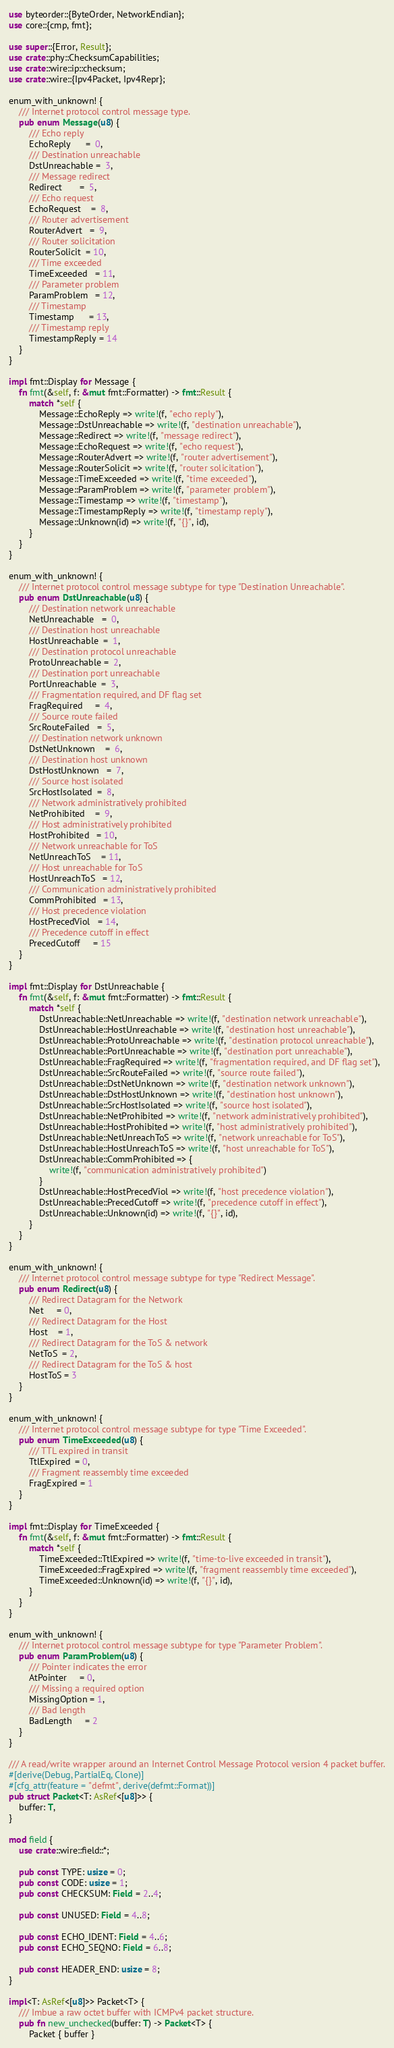Convert code to text. <code><loc_0><loc_0><loc_500><loc_500><_Rust_>use byteorder::{ByteOrder, NetworkEndian};
use core::{cmp, fmt};

use super::{Error, Result};
use crate::phy::ChecksumCapabilities;
use crate::wire::ip::checksum;
use crate::wire::{Ipv4Packet, Ipv4Repr};

enum_with_unknown! {
    /// Internet protocol control message type.
    pub enum Message(u8) {
        /// Echo reply
        EchoReply      =  0,
        /// Destination unreachable
        DstUnreachable =  3,
        /// Message redirect
        Redirect       =  5,
        /// Echo request
        EchoRequest    =  8,
        /// Router advertisement
        RouterAdvert   =  9,
        /// Router solicitation
        RouterSolicit  = 10,
        /// Time exceeded
        TimeExceeded   = 11,
        /// Parameter problem
        ParamProblem   = 12,
        /// Timestamp
        Timestamp      = 13,
        /// Timestamp reply
        TimestampReply = 14
    }
}

impl fmt::Display for Message {
    fn fmt(&self, f: &mut fmt::Formatter) -> fmt::Result {
        match *self {
            Message::EchoReply => write!(f, "echo reply"),
            Message::DstUnreachable => write!(f, "destination unreachable"),
            Message::Redirect => write!(f, "message redirect"),
            Message::EchoRequest => write!(f, "echo request"),
            Message::RouterAdvert => write!(f, "router advertisement"),
            Message::RouterSolicit => write!(f, "router solicitation"),
            Message::TimeExceeded => write!(f, "time exceeded"),
            Message::ParamProblem => write!(f, "parameter problem"),
            Message::Timestamp => write!(f, "timestamp"),
            Message::TimestampReply => write!(f, "timestamp reply"),
            Message::Unknown(id) => write!(f, "{}", id),
        }
    }
}

enum_with_unknown! {
    /// Internet protocol control message subtype for type "Destination Unreachable".
    pub enum DstUnreachable(u8) {
        /// Destination network unreachable
        NetUnreachable   =  0,
        /// Destination host unreachable
        HostUnreachable  =  1,
        /// Destination protocol unreachable
        ProtoUnreachable =  2,
        /// Destination port unreachable
        PortUnreachable  =  3,
        /// Fragmentation required, and DF flag set
        FragRequired     =  4,
        /// Source route failed
        SrcRouteFailed   =  5,
        /// Destination network unknown
        DstNetUnknown    =  6,
        /// Destination host unknown
        DstHostUnknown   =  7,
        /// Source host isolated
        SrcHostIsolated  =  8,
        /// Network administratively prohibited
        NetProhibited    =  9,
        /// Host administratively prohibited
        HostProhibited   = 10,
        /// Network unreachable for ToS
        NetUnreachToS    = 11,
        /// Host unreachable for ToS
        HostUnreachToS   = 12,
        /// Communication administratively prohibited
        CommProhibited   = 13,
        /// Host precedence violation
        HostPrecedViol   = 14,
        /// Precedence cutoff in effect
        PrecedCutoff     = 15
    }
}

impl fmt::Display for DstUnreachable {
    fn fmt(&self, f: &mut fmt::Formatter) -> fmt::Result {
        match *self {
            DstUnreachable::NetUnreachable => write!(f, "destination network unreachable"),
            DstUnreachable::HostUnreachable => write!(f, "destination host unreachable"),
            DstUnreachable::ProtoUnreachable => write!(f, "destination protocol unreachable"),
            DstUnreachable::PortUnreachable => write!(f, "destination port unreachable"),
            DstUnreachable::FragRequired => write!(f, "fragmentation required, and DF flag set"),
            DstUnreachable::SrcRouteFailed => write!(f, "source route failed"),
            DstUnreachable::DstNetUnknown => write!(f, "destination network unknown"),
            DstUnreachable::DstHostUnknown => write!(f, "destination host unknown"),
            DstUnreachable::SrcHostIsolated => write!(f, "source host isolated"),
            DstUnreachable::NetProhibited => write!(f, "network administratively prohibited"),
            DstUnreachable::HostProhibited => write!(f, "host administratively prohibited"),
            DstUnreachable::NetUnreachToS => write!(f, "network unreachable for ToS"),
            DstUnreachable::HostUnreachToS => write!(f, "host unreachable for ToS"),
            DstUnreachable::CommProhibited => {
                write!(f, "communication administratively prohibited")
            }
            DstUnreachable::HostPrecedViol => write!(f, "host precedence violation"),
            DstUnreachable::PrecedCutoff => write!(f, "precedence cutoff in effect"),
            DstUnreachable::Unknown(id) => write!(f, "{}", id),
        }
    }
}

enum_with_unknown! {
    /// Internet protocol control message subtype for type "Redirect Message".
    pub enum Redirect(u8) {
        /// Redirect Datagram for the Network
        Net     = 0,
        /// Redirect Datagram for the Host
        Host    = 1,
        /// Redirect Datagram for the ToS & network
        NetToS  = 2,
        /// Redirect Datagram for the ToS & host
        HostToS = 3
    }
}

enum_with_unknown! {
    /// Internet protocol control message subtype for type "Time Exceeded".
    pub enum TimeExceeded(u8) {
        /// TTL expired in transit
        TtlExpired  = 0,
        /// Fragment reassembly time exceeded
        FragExpired = 1
    }
}

impl fmt::Display for TimeExceeded {
    fn fmt(&self, f: &mut fmt::Formatter) -> fmt::Result {
        match *self {
            TimeExceeded::TtlExpired => write!(f, "time-to-live exceeded in transit"),
            TimeExceeded::FragExpired => write!(f, "fragment reassembly time exceeded"),
            TimeExceeded::Unknown(id) => write!(f, "{}", id),
        }
    }
}

enum_with_unknown! {
    /// Internet protocol control message subtype for type "Parameter Problem".
    pub enum ParamProblem(u8) {
        /// Pointer indicates the error
        AtPointer     = 0,
        /// Missing a required option
        MissingOption = 1,
        /// Bad length
        BadLength     = 2
    }
}

/// A read/write wrapper around an Internet Control Message Protocol version 4 packet buffer.
#[derive(Debug, PartialEq, Clone)]
#[cfg_attr(feature = "defmt", derive(defmt::Format))]
pub struct Packet<T: AsRef<[u8]>> {
    buffer: T,
}

mod field {
    use crate::wire::field::*;

    pub const TYPE: usize = 0;
    pub const CODE: usize = 1;
    pub const CHECKSUM: Field = 2..4;

    pub const UNUSED: Field = 4..8;

    pub const ECHO_IDENT: Field = 4..6;
    pub const ECHO_SEQNO: Field = 6..8;

    pub const HEADER_END: usize = 8;
}

impl<T: AsRef<[u8]>> Packet<T> {
    /// Imbue a raw octet buffer with ICMPv4 packet structure.
    pub fn new_unchecked(buffer: T) -> Packet<T> {
        Packet { buffer }</code> 